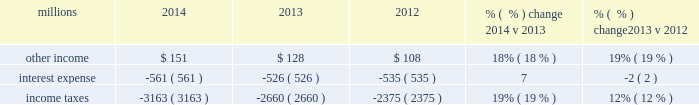Related expenses incurred by our logistics subsidiaries for external transportation and increased crew transportation and lodging due to volumes and a slower network .
In addition , higher consulting fees and higher contract expenses ( including equipment maintenance ) increased costs compared to 2013 .
Locomotive and freight car material expenses increased in 2014 compared to 2013 due to additional volumes , including the impact of activating stored equipment to address operational issues caused by demand and a slower network .
Expenses for purchased services increased 10% ( 10 % ) in 2013 compared to 2012 due to logistics management fees , an increase in locomotive overhauls and repairs on jointly owned property .
Depreciation 2013 the majority of depreciation relates to road property , including rail , ties , ballast , and other track material .
Depreciation was up 7% ( 7 % ) compared to 2013 .
A higher depreciable asset base , reflecting higher ongoing capital spending drove the increase .
Depreciation was up 1% ( 1 % ) in 2013 compared to 2012 .
Recent depreciation studies allowed us to use longer estimated service lives for certain equipment , which partially offset the impact of a higher depreciable asset base resulting from larger capital spending in recent years .
Equipment and other rents 2013 equipment and other rents expense primarily includes rental expense that the railroad pays for freight cars owned by other railroads or private companies ; freight car , intermodal , and locomotive leases ; and office and other rent expenses .
Higher intermodal volumes and longer cycle times increased short-term freight car rental expense in 2014 compared to 2013 .
Lower equipment leases essentially offset the higher freight car rental expense , as we exercised purchase options on some of our leased equipment .
Additional container costs resulting from the logistics management arrangement , and increased automotive shipments , partially offset by lower cycle times drove a $ 51 million increase in our short-term freight car rental expense in 2013 versus 2012 .
Conversely , lower locomotive and freight car lease expenses partially offset the higher freight car rental expense .
Other 2013 other expenses include state and local taxes , freight , equipment and property damage , utilities , insurance , personal injury , environmental , employee travel , telephone and cellular , computer software , bad debt , and other general expenses .
Higher property taxes , personal injury expense and utilities costs partially offset by lower environmental expense and costs associated with damaged freight drove the increase in other costs in 2014 compared to 2013 .
Higher property taxes and costs associated with damaged freight and property increased other costs in 2013 compared to 2012 .
Continued improvement in our safety performance and lower estimated liability for personal injury , which reduced our personal injury expense year-over-year , partially offset increases in other costs .
Non-operating items millions 2014 2013 2012 % (  % ) change 2014 v 2013 % (  % ) change 2013 v 2012 .
Other income 2013 other income increased in 2014 versus 2013 due to higher gains from real estate sales and a sale of a permanent easement .
These gains were partially offset by higher environmental costs on non-operating property in 2014 and lower lease income due to the $ 17 million settlement of a land lease contract in 2013 .
Other income increased in 2013 versus 2012 due to higher gains from real estate sales and increased lease income , including the favorable impact from the $ 17 million settlement of a land lease contract .
These increases were partially offset by interest received from a tax refund in 2012. .
Depreciation was up how much in total for 2013 and 2012? 
Computations: (1% + 7%)
Answer: 0.08. 